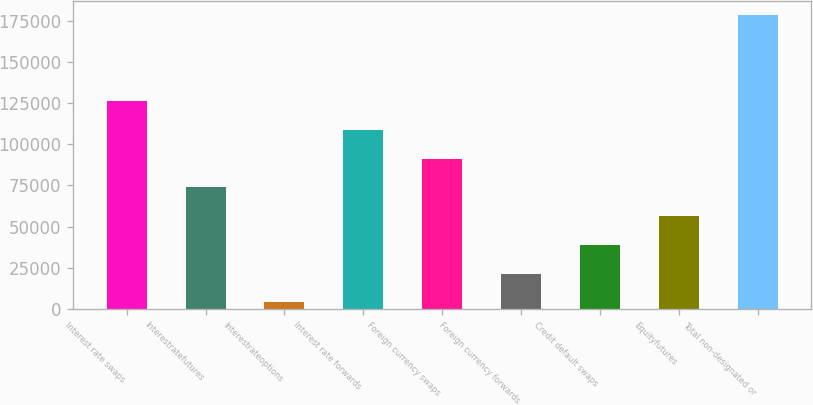<chart> <loc_0><loc_0><loc_500><loc_500><bar_chart><fcel>Interest rate swaps<fcel>Interestratefutures<fcel>Interestrateoptions<fcel>Interest rate forwards<fcel>Foreign currency swaps<fcel>Foreign currency forwards<fcel>Credit default swaps<fcel>Equityfutures<fcel>Total non-designated or<nl><fcel>126024<fcel>73749.2<fcel>4050<fcel>108599<fcel>91174<fcel>21474.8<fcel>38899.6<fcel>56324.4<fcel>178298<nl></chart> 